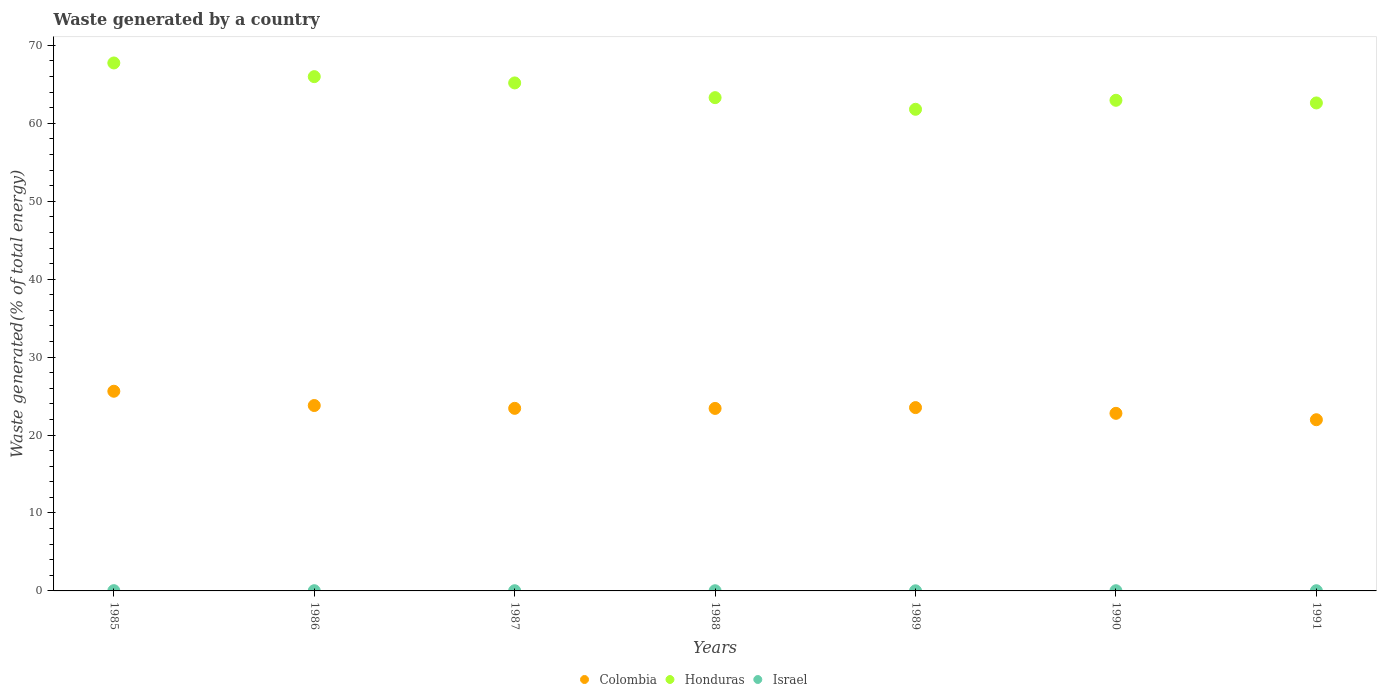How many different coloured dotlines are there?
Keep it short and to the point. 3. Is the number of dotlines equal to the number of legend labels?
Offer a terse response. Yes. What is the total waste generated in Honduras in 1989?
Ensure brevity in your answer.  61.8. Across all years, what is the maximum total waste generated in Honduras?
Make the answer very short. 67.74. Across all years, what is the minimum total waste generated in Colombia?
Provide a succinct answer. 21.97. In which year was the total waste generated in Israel maximum?
Give a very brief answer. 1985. In which year was the total waste generated in Honduras minimum?
Offer a very short reply. 1989. What is the total total waste generated in Colombia in the graph?
Provide a succinct answer. 164.53. What is the difference between the total waste generated in Colombia in 1987 and that in 1991?
Give a very brief answer. 1.46. What is the difference between the total waste generated in Israel in 1988 and the total waste generated in Honduras in 1987?
Your response must be concise. -65.16. What is the average total waste generated in Israel per year?
Offer a very short reply. 0.03. In the year 1989, what is the difference between the total waste generated in Israel and total waste generated in Honduras?
Provide a succinct answer. -61.78. In how many years, is the total waste generated in Colombia greater than 8 %?
Your answer should be very brief. 7. What is the ratio of the total waste generated in Colombia in 1985 to that in 1991?
Provide a succinct answer. 1.17. Is the total waste generated in Honduras in 1989 less than that in 1991?
Make the answer very short. Yes. What is the difference between the highest and the second highest total waste generated in Israel?
Provide a succinct answer. 0.01. What is the difference between the highest and the lowest total waste generated in Honduras?
Your answer should be compact. 5.94. Is the sum of the total waste generated in Israel in 1985 and 1986 greater than the maximum total waste generated in Honduras across all years?
Make the answer very short. No. Is the total waste generated in Israel strictly greater than the total waste generated in Colombia over the years?
Offer a terse response. No. Is the total waste generated in Israel strictly less than the total waste generated in Colombia over the years?
Your response must be concise. Yes. How many dotlines are there?
Offer a very short reply. 3. What is the difference between two consecutive major ticks on the Y-axis?
Your answer should be compact. 10. Are the values on the major ticks of Y-axis written in scientific E-notation?
Provide a short and direct response. No. Does the graph contain any zero values?
Provide a succinct answer. No. Where does the legend appear in the graph?
Your answer should be very brief. Bottom center. How many legend labels are there?
Give a very brief answer. 3. How are the legend labels stacked?
Offer a terse response. Horizontal. What is the title of the graph?
Your answer should be compact. Waste generated by a country. Does "Madagascar" appear as one of the legend labels in the graph?
Your response must be concise. No. What is the label or title of the Y-axis?
Make the answer very short. Waste generated(% of total energy). What is the Waste generated(% of total energy) of Colombia in 1985?
Offer a very short reply. 25.62. What is the Waste generated(% of total energy) in Honduras in 1985?
Provide a short and direct response. 67.74. What is the Waste generated(% of total energy) in Israel in 1985?
Keep it short and to the point. 0.03. What is the Waste generated(% of total energy) in Colombia in 1986?
Offer a terse response. 23.79. What is the Waste generated(% of total energy) in Honduras in 1986?
Give a very brief answer. 65.99. What is the Waste generated(% of total energy) in Israel in 1986?
Your answer should be compact. 0.03. What is the Waste generated(% of total energy) of Colombia in 1987?
Give a very brief answer. 23.43. What is the Waste generated(% of total energy) in Honduras in 1987?
Make the answer very short. 65.18. What is the Waste generated(% of total energy) of Israel in 1987?
Offer a very short reply. 0.03. What is the Waste generated(% of total energy) of Colombia in 1988?
Your answer should be very brief. 23.42. What is the Waste generated(% of total energy) in Honduras in 1988?
Offer a very short reply. 63.29. What is the Waste generated(% of total energy) of Israel in 1988?
Keep it short and to the point. 0.02. What is the Waste generated(% of total energy) in Colombia in 1989?
Your answer should be very brief. 23.52. What is the Waste generated(% of total energy) in Honduras in 1989?
Offer a very short reply. 61.8. What is the Waste generated(% of total energy) in Israel in 1989?
Provide a short and direct response. 0.01. What is the Waste generated(% of total energy) of Colombia in 1990?
Your answer should be very brief. 22.79. What is the Waste generated(% of total energy) of Honduras in 1990?
Provide a succinct answer. 62.95. What is the Waste generated(% of total energy) in Israel in 1990?
Offer a terse response. 0.03. What is the Waste generated(% of total energy) of Colombia in 1991?
Give a very brief answer. 21.97. What is the Waste generated(% of total energy) in Honduras in 1991?
Give a very brief answer. 62.61. What is the Waste generated(% of total energy) of Israel in 1991?
Ensure brevity in your answer.  0.03. Across all years, what is the maximum Waste generated(% of total energy) of Colombia?
Provide a succinct answer. 25.62. Across all years, what is the maximum Waste generated(% of total energy) of Honduras?
Your answer should be very brief. 67.74. Across all years, what is the maximum Waste generated(% of total energy) in Israel?
Your response must be concise. 0.03. Across all years, what is the minimum Waste generated(% of total energy) in Colombia?
Ensure brevity in your answer.  21.97. Across all years, what is the minimum Waste generated(% of total energy) in Honduras?
Provide a succinct answer. 61.8. Across all years, what is the minimum Waste generated(% of total energy) in Israel?
Give a very brief answer. 0.01. What is the total Waste generated(% of total energy) of Colombia in the graph?
Your response must be concise. 164.53. What is the total Waste generated(% of total energy) of Honduras in the graph?
Ensure brevity in your answer.  449.57. What is the total Waste generated(% of total energy) of Israel in the graph?
Provide a succinct answer. 0.18. What is the difference between the Waste generated(% of total energy) of Colombia in 1985 and that in 1986?
Offer a terse response. 1.83. What is the difference between the Waste generated(% of total energy) in Honduras in 1985 and that in 1986?
Offer a terse response. 1.75. What is the difference between the Waste generated(% of total energy) of Israel in 1985 and that in 1986?
Offer a terse response. 0.01. What is the difference between the Waste generated(% of total energy) in Colombia in 1985 and that in 1987?
Your response must be concise. 2.19. What is the difference between the Waste generated(% of total energy) in Honduras in 1985 and that in 1987?
Offer a terse response. 2.56. What is the difference between the Waste generated(% of total energy) of Israel in 1985 and that in 1987?
Offer a very short reply. 0.01. What is the difference between the Waste generated(% of total energy) of Colombia in 1985 and that in 1988?
Make the answer very short. 2.2. What is the difference between the Waste generated(% of total energy) in Honduras in 1985 and that in 1988?
Your answer should be compact. 4.45. What is the difference between the Waste generated(% of total energy) in Israel in 1985 and that in 1988?
Make the answer very short. 0.01. What is the difference between the Waste generated(% of total energy) in Colombia in 1985 and that in 1989?
Make the answer very short. 2.1. What is the difference between the Waste generated(% of total energy) of Honduras in 1985 and that in 1989?
Your answer should be very brief. 5.94. What is the difference between the Waste generated(% of total energy) in Israel in 1985 and that in 1989?
Ensure brevity in your answer.  0.02. What is the difference between the Waste generated(% of total energy) of Colombia in 1985 and that in 1990?
Provide a short and direct response. 2.83. What is the difference between the Waste generated(% of total energy) in Honduras in 1985 and that in 1990?
Give a very brief answer. 4.79. What is the difference between the Waste generated(% of total energy) of Israel in 1985 and that in 1990?
Your answer should be very brief. 0.01. What is the difference between the Waste generated(% of total energy) in Colombia in 1985 and that in 1991?
Ensure brevity in your answer.  3.65. What is the difference between the Waste generated(% of total energy) in Honduras in 1985 and that in 1991?
Provide a succinct answer. 5.13. What is the difference between the Waste generated(% of total energy) in Israel in 1985 and that in 1991?
Provide a short and direct response. 0.01. What is the difference between the Waste generated(% of total energy) of Colombia in 1986 and that in 1987?
Offer a terse response. 0.36. What is the difference between the Waste generated(% of total energy) of Honduras in 1986 and that in 1987?
Your answer should be compact. 0.81. What is the difference between the Waste generated(% of total energy) of Israel in 1986 and that in 1987?
Provide a short and direct response. 0. What is the difference between the Waste generated(% of total energy) of Colombia in 1986 and that in 1988?
Keep it short and to the point. 0.37. What is the difference between the Waste generated(% of total energy) in Honduras in 1986 and that in 1988?
Your answer should be compact. 2.7. What is the difference between the Waste generated(% of total energy) of Israel in 1986 and that in 1988?
Provide a succinct answer. 0. What is the difference between the Waste generated(% of total energy) of Colombia in 1986 and that in 1989?
Your answer should be very brief. 0.27. What is the difference between the Waste generated(% of total energy) of Honduras in 1986 and that in 1989?
Offer a terse response. 4.19. What is the difference between the Waste generated(% of total energy) of Israel in 1986 and that in 1989?
Ensure brevity in your answer.  0.01. What is the difference between the Waste generated(% of total energy) in Colombia in 1986 and that in 1990?
Your response must be concise. 1. What is the difference between the Waste generated(% of total energy) in Honduras in 1986 and that in 1990?
Offer a very short reply. 3.03. What is the difference between the Waste generated(% of total energy) in Israel in 1986 and that in 1990?
Provide a succinct answer. 0. What is the difference between the Waste generated(% of total energy) in Colombia in 1986 and that in 1991?
Make the answer very short. 1.82. What is the difference between the Waste generated(% of total energy) in Honduras in 1986 and that in 1991?
Provide a short and direct response. 3.37. What is the difference between the Waste generated(% of total energy) of Israel in 1986 and that in 1991?
Make the answer very short. 0. What is the difference between the Waste generated(% of total energy) in Colombia in 1987 and that in 1988?
Provide a short and direct response. 0.01. What is the difference between the Waste generated(% of total energy) of Honduras in 1987 and that in 1988?
Your response must be concise. 1.89. What is the difference between the Waste generated(% of total energy) of Israel in 1987 and that in 1988?
Provide a short and direct response. 0. What is the difference between the Waste generated(% of total energy) in Colombia in 1987 and that in 1989?
Your answer should be very brief. -0.1. What is the difference between the Waste generated(% of total energy) in Honduras in 1987 and that in 1989?
Provide a short and direct response. 3.38. What is the difference between the Waste generated(% of total energy) in Israel in 1987 and that in 1989?
Make the answer very short. 0.01. What is the difference between the Waste generated(% of total energy) of Colombia in 1987 and that in 1990?
Give a very brief answer. 0.64. What is the difference between the Waste generated(% of total energy) of Honduras in 1987 and that in 1990?
Your answer should be very brief. 2.23. What is the difference between the Waste generated(% of total energy) of Israel in 1987 and that in 1990?
Your answer should be compact. -0. What is the difference between the Waste generated(% of total energy) of Colombia in 1987 and that in 1991?
Your answer should be very brief. 1.46. What is the difference between the Waste generated(% of total energy) of Honduras in 1987 and that in 1991?
Your answer should be very brief. 2.57. What is the difference between the Waste generated(% of total energy) in Israel in 1987 and that in 1991?
Provide a short and direct response. -0. What is the difference between the Waste generated(% of total energy) of Colombia in 1988 and that in 1989?
Provide a succinct answer. -0.11. What is the difference between the Waste generated(% of total energy) in Honduras in 1988 and that in 1989?
Ensure brevity in your answer.  1.49. What is the difference between the Waste generated(% of total energy) of Israel in 1988 and that in 1989?
Provide a succinct answer. 0.01. What is the difference between the Waste generated(% of total energy) of Colombia in 1988 and that in 1990?
Make the answer very short. 0.63. What is the difference between the Waste generated(% of total energy) of Honduras in 1988 and that in 1990?
Make the answer very short. 0.34. What is the difference between the Waste generated(% of total energy) of Israel in 1988 and that in 1990?
Provide a short and direct response. -0. What is the difference between the Waste generated(% of total energy) of Colombia in 1988 and that in 1991?
Offer a very short reply. 1.45. What is the difference between the Waste generated(% of total energy) of Honduras in 1988 and that in 1991?
Your answer should be compact. 0.68. What is the difference between the Waste generated(% of total energy) of Israel in 1988 and that in 1991?
Your answer should be very brief. -0. What is the difference between the Waste generated(% of total energy) in Colombia in 1989 and that in 1990?
Your answer should be very brief. 0.74. What is the difference between the Waste generated(% of total energy) of Honduras in 1989 and that in 1990?
Keep it short and to the point. -1.16. What is the difference between the Waste generated(% of total energy) in Israel in 1989 and that in 1990?
Offer a very short reply. -0.01. What is the difference between the Waste generated(% of total energy) in Colombia in 1989 and that in 1991?
Your answer should be very brief. 1.56. What is the difference between the Waste generated(% of total energy) in Honduras in 1989 and that in 1991?
Keep it short and to the point. -0.81. What is the difference between the Waste generated(% of total energy) in Israel in 1989 and that in 1991?
Your answer should be compact. -0.01. What is the difference between the Waste generated(% of total energy) in Colombia in 1990 and that in 1991?
Your answer should be compact. 0.82. What is the difference between the Waste generated(% of total energy) of Honduras in 1990 and that in 1991?
Offer a terse response. 0.34. What is the difference between the Waste generated(% of total energy) of Colombia in 1985 and the Waste generated(% of total energy) of Honduras in 1986?
Offer a terse response. -40.37. What is the difference between the Waste generated(% of total energy) of Colombia in 1985 and the Waste generated(% of total energy) of Israel in 1986?
Keep it short and to the point. 25.59. What is the difference between the Waste generated(% of total energy) of Honduras in 1985 and the Waste generated(% of total energy) of Israel in 1986?
Offer a very short reply. 67.71. What is the difference between the Waste generated(% of total energy) in Colombia in 1985 and the Waste generated(% of total energy) in Honduras in 1987?
Offer a terse response. -39.56. What is the difference between the Waste generated(% of total energy) in Colombia in 1985 and the Waste generated(% of total energy) in Israel in 1987?
Give a very brief answer. 25.59. What is the difference between the Waste generated(% of total energy) of Honduras in 1985 and the Waste generated(% of total energy) of Israel in 1987?
Offer a very short reply. 67.72. What is the difference between the Waste generated(% of total energy) in Colombia in 1985 and the Waste generated(% of total energy) in Honduras in 1988?
Give a very brief answer. -37.67. What is the difference between the Waste generated(% of total energy) of Colombia in 1985 and the Waste generated(% of total energy) of Israel in 1988?
Keep it short and to the point. 25.6. What is the difference between the Waste generated(% of total energy) in Honduras in 1985 and the Waste generated(% of total energy) in Israel in 1988?
Your answer should be compact. 67.72. What is the difference between the Waste generated(% of total energy) in Colombia in 1985 and the Waste generated(% of total energy) in Honduras in 1989?
Offer a terse response. -36.18. What is the difference between the Waste generated(% of total energy) in Colombia in 1985 and the Waste generated(% of total energy) in Israel in 1989?
Ensure brevity in your answer.  25.61. What is the difference between the Waste generated(% of total energy) of Honduras in 1985 and the Waste generated(% of total energy) of Israel in 1989?
Give a very brief answer. 67.73. What is the difference between the Waste generated(% of total energy) of Colombia in 1985 and the Waste generated(% of total energy) of Honduras in 1990?
Provide a succinct answer. -37.33. What is the difference between the Waste generated(% of total energy) of Colombia in 1985 and the Waste generated(% of total energy) of Israel in 1990?
Ensure brevity in your answer.  25.59. What is the difference between the Waste generated(% of total energy) in Honduras in 1985 and the Waste generated(% of total energy) in Israel in 1990?
Your answer should be very brief. 67.72. What is the difference between the Waste generated(% of total energy) in Colombia in 1985 and the Waste generated(% of total energy) in Honduras in 1991?
Ensure brevity in your answer.  -36.99. What is the difference between the Waste generated(% of total energy) in Colombia in 1985 and the Waste generated(% of total energy) in Israel in 1991?
Offer a very short reply. 25.59. What is the difference between the Waste generated(% of total energy) in Honduras in 1985 and the Waste generated(% of total energy) in Israel in 1991?
Your answer should be compact. 67.72. What is the difference between the Waste generated(% of total energy) of Colombia in 1986 and the Waste generated(% of total energy) of Honduras in 1987?
Keep it short and to the point. -41.39. What is the difference between the Waste generated(% of total energy) in Colombia in 1986 and the Waste generated(% of total energy) in Israel in 1987?
Your answer should be very brief. 23.76. What is the difference between the Waste generated(% of total energy) in Honduras in 1986 and the Waste generated(% of total energy) in Israel in 1987?
Provide a short and direct response. 65.96. What is the difference between the Waste generated(% of total energy) in Colombia in 1986 and the Waste generated(% of total energy) in Honduras in 1988?
Keep it short and to the point. -39.5. What is the difference between the Waste generated(% of total energy) of Colombia in 1986 and the Waste generated(% of total energy) of Israel in 1988?
Your answer should be compact. 23.77. What is the difference between the Waste generated(% of total energy) of Honduras in 1986 and the Waste generated(% of total energy) of Israel in 1988?
Offer a terse response. 65.97. What is the difference between the Waste generated(% of total energy) in Colombia in 1986 and the Waste generated(% of total energy) in Honduras in 1989?
Your answer should be very brief. -38.01. What is the difference between the Waste generated(% of total energy) of Colombia in 1986 and the Waste generated(% of total energy) of Israel in 1989?
Offer a very short reply. 23.77. What is the difference between the Waste generated(% of total energy) of Honduras in 1986 and the Waste generated(% of total energy) of Israel in 1989?
Your answer should be compact. 65.97. What is the difference between the Waste generated(% of total energy) in Colombia in 1986 and the Waste generated(% of total energy) in Honduras in 1990?
Ensure brevity in your answer.  -39.17. What is the difference between the Waste generated(% of total energy) of Colombia in 1986 and the Waste generated(% of total energy) of Israel in 1990?
Keep it short and to the point. 23.76. What is the difference between the Waste generated(% of total energy) in Honduras in 1986 and the Waste generated(% of total energy) in Israel in 1990?
Make the answer very short. 65.96. What is the difference between the Waste generated(% of total energy) of Colombia in 1986 and the Waste generated(% of total energy) of Honduras in 1991?
Your answer should be compact. -38.82. What is the difference between the Waste generated(% of total energy) of Colombia in 1986 and the Waste generated(% of total energy) of Israel in 1991?
Your response must be concise. 23.76. What is the difference between the Waste generated(% of total energy) of Honduras in 1986 and the Waste generated(% of total energy) of Israel in 1991?
Provide a succinct answer. 65.96. What is the difference between the Waste generated(% of total energy) of Colombia in 1987 and the Waste generated(% of total energy) of Honduras in 1988?
Provide a short and direct response. -39.87. What is the difference between the Waste generated(% of total energy) of Colombia in 1987 and the Waste generated(% of total energy) of Israel in 1988?
Provide a short and direct response. 23.4. What is the difference between the Waste generated(% of total energy) of Honduras in 1987 and the Waste generated(% of total energy) of Israel in 1988?
Your answer should be compact. 65.16. What is the difference between the Waste generated(% of total energy) in Colombia in 1987 and the Waste generated(% of total energy) in Honduras in 1989?
Keep it short and to the point. -38.37. What is the difference between the Waste generated(% of total energy) in Colombia in 1987 and the Waste generated(% of total energy) in Israel in 1989?
Give a very brief answer. 23.41. What is the difference between the Waste generated(% of total energy) of Honduras in 1987 and the Waste generated(% of total energy) of Israel in 1989?
Provide a short and direct response. 65.17. What is the difference between the Waste generated(% of total energy) of Colombia in 1987 and the Waste generated(% of total energy) of Honduras in 1990?
Ensure brevity in your answer.  -39.53. What is the difference between the Waste generated(% of total energy) in Colombia in 1987 and the Waste generated(% of total energy) in Israel in 1990?
Provide a short and direct response. 23.4. What is the difference between the Waste generated(% of total energy) in Honduras in 1987 and the Waste generated(% of total energy) in Israel in 1990?
Your answer should be compact. 65.16. What is the difference between the Waste generated(% of total energy) of Colombia in 1987 and the Waste generated(% of total energy) of Honduras in 1991?
Offer a terse response. -39.19. What is the difference between the Waste generated(% of total energy) in Colombia in 1987 and the Waste generated(% of total energy) in Israel in 1991?
Offer a very short reply. 23.4. What is the difference between the Waste generated(% of total energy) in Honduras in 1987 and the Waste generated(% of total energy) in Israel in 1991?
Keep it short and to the point. 65.16. What is the difference between the Waste generated(% of total energy) in Colombia in 1988 and the Waste generated(% of total energy) in Honduras in 1989?
Your response must be concise. -38.38. What is the difference between the Waste generated(% of total energy) of Colombia in 1988 and the Waste generated(% of total energy) of Israel in 1989?
Keep it short and to the point. 23.4. What is the difference between the Waste generated(% of total energy) of Honduras in 1988 and the Waste generated(% of total energy) of Israel in 1989?
Offer a very short reply. 63.28. What is the difference between the Waste generated(% of total energy) of Colombia in 1988 and the Waste generated(% of total energy) of Honduras in 1990?
Provide a succinct answer. -39.54. What is the difference between the Waste generated(% of total energy) in Colombia in 1988 and the Waste generated(% of total energy) in Israel in 1990?
Provide a succinct answer. 23.39. What is the difference between the Waste generated(% of total energy) of Honduras in 1988 and the Waste generated(% of total energy) of Israel in 1990?
Your answer should be very brief. 63.27. What is the difference between the Waste generated(% of total energy) in Colombia in 1988 and the Waste generated(% of total energy) in Honduras in 1991?
Offer a terse response. -39.2. What is the difference between the Waste generated(% of total energy) of Colombia in 1988 and the Waste generated(% of total energy) of Israel in 1991?
Your response must be concise. 23.39. What is the difference between the Waste generated(% of total energy) of Honduras in 1988 and the Waste generated(% of total energy) of Israel in 1991?
Make the answer very short. 63.27. What is the difference between the Waste generated(% of total energy) of Colombia in 1989 and the Waste generated(% of total energy) of Honduras in 1990?
Ensure brevity in your answer.  -39.43. What is the difference between the Waste generated(% of total energy) in Colombia in 1989 and the Waste generated(% of total energy) in Israel in 1990?
Ensure brevity in your answer.  23.5. What is the difference between the Waste generated(% of total energy) in Honduras in 1989 and the Waste generated(% of total energy) in Israel in 1990?
Your answer should be compact. 61.77. What is the difference between the Waste generated(% of total energy) of Colombia in 1989 and the Waste generated(% of total energy) of Honduras in 1991?
Make the answer very short. -39.09. What is the difference between the Waste generated(% of total energy) of Colombia in 1989 and the Waste generated(% of total energy) of Israel in 1991?
Your response must be concise. 23.5. What is the difference between the Waste generated(% of total energy) in Honduras in 1989 and the Waste generated(% of total energy) in Israel in 1991?
Make the answer very short. 61.77. What is the difference between the Waste generated(% of total energy) of Colombia in 1990 and the Waste generated(% of total energy) of Honduras in 1991?
Your response must be concise. -39.83. What is the difference between the Waste generated(% of total energy) of Colombia in 1990 and the Waste generated(% of total energy) of Israel in 1991?
Offer a terse response. 22.76. What is the difference between the Waste generated(% of total energy) of Honduras in 1990 and the Waste generated(% of total energy) of Israel in 1991?
Your answer should be very brief. 62.93. What is the average Waste generated(% of total energy) in Colombia per year?
Give a very brief answer. 23.5. What is the average Waste generated(% of total energy) in Honduras per year?
Your answer should be very brief. 64.22. What is the average Waste generated(% of total energy) in Israel per year?
Give a very brief answer. 0.03. In the year 1985, what is the difference between the Waste generated(% of total energy) in Colombia and Waste generated(% of total energy) in Honduras?
Provide a short and direct response. -42.12. In the year 1985, what is the difference between the Waste generated(% of total energy) of Colombia and Waste generated(% of total energy) of Israel?
Provide a succinct answer. 25.59. In the year 1985, what is the difference between the Waste generated(% of total energy) in Honduras and Waste generated(% of total energy) in Israel?
Keep it short and to the point. 67.71. In the year 1986, what is the difference between the Waste generated(% of total energy) of Colombia and Waste generated(% of total energy) of Honduras?
Provide a succinct answer. -42.2. In the year 1986, what is the difference between the Waste generated(% of total energy) of Colombia and Waste generated(% of total energy) of Israel?
Keep it short and to the point. 23.76. In the year 1986, what is the difference between the Waste generated(% of total energy) in Honduras and Waste generated(% of total energy) in Israel?
Ensure brevity in your answer.  65.96. In the year 1987, what is the difference between the Waste generated(% of total energy) of Colombia and Waste generated(% of total energy) of Honduras?
Keep it short and to the point. -41.75. In the year 1987, what is the difference between the Waste generated(% of total energy) in Colombia and Waste generated(% of total energy) in Israel?
Provide a short and direct response. 23.4. In the year 1987, what is the difference between the Waste generated(% of total energy) of Honduras and Waste generated(% of total energy) of Israel?
Give a very brief answer. 65.16. In the year 1988, what is the difference between the Waste generated(% of total energy) of Colombia and Waste generated(% of total energy) of Honduras?
Your answer should be very brief. -39.88. In the year 1988, what is the difference between the Waste generated(% of total energy) of Colombia and Waste generated(% of total energy) of Israel?
Keep it short and to the point. 23.39. In the year 1988, what is the difference between the Waste generated(% of total energy) of Honduras and Waste generated(% of total energy) of Israel?
Ensure brevity in your answer.  63.27. In the year 1989, what is the difference between the Waste generated(% of total energy) of Colombia and Waste generated(% of total energy) of Honduras?
Make the answer very short. -38.28. In the year 1989, what is the difference between the Waste generated(% of total energy) in Colombia and Waste generated(% of total energy) in Israel?
Provide a succinct answer. 23.51. In the year 1989, what is the difference between the Waste generated(% of total energy) in Honduras and Waste generated(% of total energy) in Israel?
Offer a very short reply. 61.78. In the year 1990, what is the difference between the Waste generated(% of total energy) in Colombia and Waste generated(% of total energy) in Honduras?
Make the answer very short. -40.17. In the year 1990, what is the difference between the Waste generated(% of total energy) in Colombia and Waste generated(% of total energy) in Israel?
Provide a short and direct response. 22.76. In the year 1990, what is the difference between the Waste generated(% of total energy) of Honduras and Waste generated(% of total energy) of Israel?
Make the answer very short. 62.93. In the year 1991, what is the difference between the Waste generated(% of total energy) in Colombia and Waste generated(% of total energy) in Honduras?
Keep it short and to the point. -40.65. In the year 1991, what is the difference between the Waste generated(% of total energy) in Colombia and Waste generated(% of total energy) in Israel?
Your answer should be very brief. 21.94. In the year 1991, what is the difference between the Waste generated(% of total energy) of Honduras and Waste generated(% of total energy) of Israel?
Keep it short and to the point. 62.59. What is the ratio of the Waste generated(% of total energy) in Colombia in 1985 to that in 1986?
Ensure brevity in your answer.  1.08. What is the ratio of the Waste generated(% of total energy) in Honduras in 1985 to that in 1986?
Offer a very short reply. 1.03. What is the ratio of the Waste generated(% of total energy) in Israel in 1985 to that in 1986?
Provide a succinct answer. 1.19. What is the ratio of the Waste generated(% of total energy) of Colombia in 1985 to that in 1987?
Offer a terse response. 1.09. What is the ratio of the Waste generated(% of total energy) of Honduras in 1985 to that in 1987?
Ensure brevity in your answer.  1.04. What is the ratio of the Waste generated(% of total energy) in Israel in 1985 to that in 1987?
Your answer should be compact. 1.31. What is the ratio of the Waste generated(% of total energy) in Colombia in 1985 to that in 1988?
Provide a succinct answer. 1.09. What is the ratio of the Waste generated(% of total energy) of Honduras in 1985 to that in 1988?
Offer a terse response. 1.07. What is the ratio of the Waste generated(% of total energy) in Israel in 1985 to that in 1988?
Provide a succinct answer. 1.44. What is the ratio of the Waste generated(% of total energy) in Colombia in 1985 to that in 1989?
Provide a succinct answer. 1.09. What is the ratio of the Waste generated(% of total energy) of Honduras in 1985 to that in 1989?
Provide a short and direct response. 1.1. What is the ratio of the Waste generated(% of total energy) in Israel in 1985 to that in 1989?
Your answer should be very brief. 2.34. What is the ratio of the Waste generated(% of total energy) in Colombia in 1985 to that in 1990?
Provide a succinct answer. 1.12. What is the ratio of the Waste generated(% of total energy) of Honduras in 1985 to that in 1990?
Your answer should be very brief. 1.08. What is the ratio of the Waste generated(% of total energy) of Israel in 1985 to that in 1990?
Your answer should be compact. 1.28. What is the ratio of the Waste generated(% of total energy) of Colombia in 1985 to that in 1991?
Provide a short and direct response. 1.17. What is the ratio of the Waste generated(% of total energy) in Honduras in 1985 to that in 1991?
Your answer should be compact. 1.08. What is the ratio of the Waste generated(% of total energy) in Israel in 1985 to that in 1991?
Make the answer very short. 1.28. What is the ratio of the Waste generated(% of total energy) of Colombia in 1986 to that in 1987?
Your answer should be compact. 1.02. What is the ratio of the Waste generated(% of total energy) in Honduras in 1986 to that in 1987?
Your answer should be compact. 1.01. What is the ratio of the Waste generated(% of total energy) of Israel in 1986 to that in 1987?
Make the answer very short. 1.1. What is the ratio of the Waste generated(% of total energy) in Colombia in 1986 to that in 1988?
Your answer should be very brief. 1.02. What is the ratio of the Waste generated(% of total energy) of Honduras in 1986 to that in 1988?
Your answer should be very brief. 1.04. What is the ratio of the Waste generated(% of total energy) of Israel in 1986 to that in 1988?
Provide a succinct answer. 1.21. What is the ratio of the Waste generated(% of total energy) of Colombia in 1986 to that in 1989?
Your response must be concise. 1.01. What is the ratio of the Waste generated(% of total energy) in Honduras in 1986 to that in 1989?
Offer a terse response. 1.07. What is the ratio of the Waste generated(% of total energy) in Israel in 1986 to that in 1989?
Keep it short and to the point. 1.96. What is the ratio of the Waste generated(% of total energy) of Colombia in 1986 to that in 1990?
Offer a terse response. 1.04. What is the ratio of the Waste generated(% of total energy) of Honduras in 1986 to that in 1990?
Your answer should be compact. 1.05. What is the ratio of the Waste generated(% of total energy) of Israel in 1986 to that in 1990?
Provide a succinct answer. 1.07. What is the ratio of the Waste generated(% of total energy) in Colombia in 1986 to that in 1991?
Make the answer very short. 1.08. What is the ratio of the Waste generated(% of total energy) of Honduras in 1986 to that in 1991?
Offer a terse response. 1.05. What is the ratio of the Waste generated(% of total energy) of Israel in 1986 to that in 1991?
Offer a very short reply. 1.07. What is the ratio of the Waste generated(% of total energy) of Honduras in 1987 to that in 1988?
Provide a succinct answer. 1.03. What is the ratio of the Waste generated(% of total energy) in Israel in 1987 to that in 1988?
Give a very brief answer. 1.09. What is the ratio of the Waste generated(% of total energy) of Colombia in 1987 to that in 1989?
Offer a terse response. 1. What is the ratio of the Waste generated(% of total energy) of Honduras in 1987 to that in 1989?
Your answer should be very brief. 1.05. What is the ratio of the Waste generated(% of total energy) of Israel in 1987 to that in 1989?
Give a very brief answer. 1.78. What is the ratio of the Waste generated(% of total energy) of Colombia in 1987 to that in 1990?
Give a very brief answer. 1.03. What is the ratio of the Waste generated(% of total energy) in Honduras in 1987 to that in 1990?
Provide a short and direct response. 1.04. What is the ratio of the Waste generated(% of total energy) in Israel in 1987 to that in 1990?
Your answer should be compact. 0.97. What is the ratio of the Waste generated(% of total energy) of Colombia in 1987 to that in 1991?
Provide a succinct answer. 1.07. What is the ratio of the Waste generated(% of total energy) in Honduras in 1987 to that in 1991?
Your answer should be compact. 1.04. What is the ratio of the Waste generated(% of total energy) in Israel in 1987 to that in 1991?
Keep it short and to the point. 0.97. What is the ratio of the Waste generated(% of total energy) in Honduras in 1988 to that in 1989?
Offer a very short reply. 1.02. What is the ratio of the Waste generated(% of total energy) of Israel in 1988 to that in 1989?
Your answer should be very brief. 1.62. What is the ratio of the Waste generated(% of total energy) of Colombia in 1988 to that in 1990?
Provide a succinct answer. 1.03. What is the ratio of the Waste generated(% of total energy) of Honduras in 1988 to that in 1990?
Make the answer very short. 1.01. What is the ratio of the Waste generated(% of total energy) in Israel in 1988 to that in 1990?
Offer a terse response. 0.89. What is the ratio of the Waste generated(% of total energy) of Colombia in 1988 to that in 1991?
Provide a succinct answer. 1.07. What is the ratio of the Waste generated(% of total energy) in Honduras in 1988 to that in 1991?
Give a very brief answer. 1.01. What is the ratio of the Waste generated(% of total energy) in Israel in 1988 to that in 1991?
Your response must be concise. 0.89. What is the ratio of the Waste generated(% of total energy) in Colombia in 1989 to that in 1990?
Your answer should be very brief. 1.03. What is the ratio of the Waste generated(% of total energy) of Honduras in 1989 to that in 1990?
Offer a very short reply. 0.98. What is the ratio of the Waste generated(% of total energy) in Israel in 1989 to that in 1990?
Provide a succinct answer. 0.55. What is the ratio of the Waste generated(% of total energy) of Colombia in 1989 to that in 1991?
Your answer should be compact. 1.07. What is the ratio of the Waste generated(% of total energy) of Honduras in 1989 to that in 1991?
Keep it short and to the point. 0.99. What is the ratio of the Waste generated(% of total energy) in Israel in 1989 to that in 1991?
Offer a very short reply. 0.55. What is the ratio of the Waste generated(% of total energy) of Colombia in 1990 to that in 1991?
Ensure brevity in your answer.  1.04. What is the ratio of the Waste generated(% of total energy) of Honduras in 1990 to that in 1991?
Offer a terse response. 1.01. What is the difference between the highest and the second highest Waste generated(% of total energy) in Colombia?
Offer a terse response. 1.83. What is the difference between the highest and the second highest Waste generated(% of total energy) of Honduras?
Give a very brief answer. 1.75. What is the difference between the highest and the second highest Waste generated(% of total energy) of Israel?
Make the answer very short. 0.01. What is the difference between the highest and the lowest Waste generated(% of total energy) in Colombia?
Your response must be concise. 3.65. What is the difference between the highest and the lowest Waste generated(% of total energy) in Honduras?
Your answer should be very brief. 5.94. What is the difference between the highest and the lowest Waste generated(% of total energy) in Israel?
Keep it short and to the point. 0.02. 